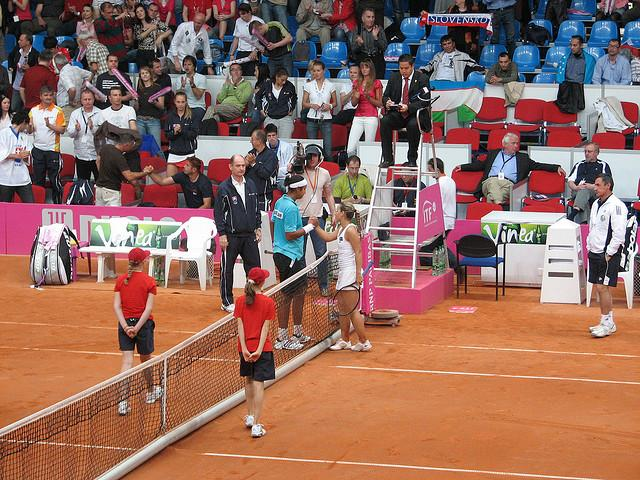At which point in the match are these players? Please explain your reasoning. end. After a tennis match is over, the players traditionally shake hands. 